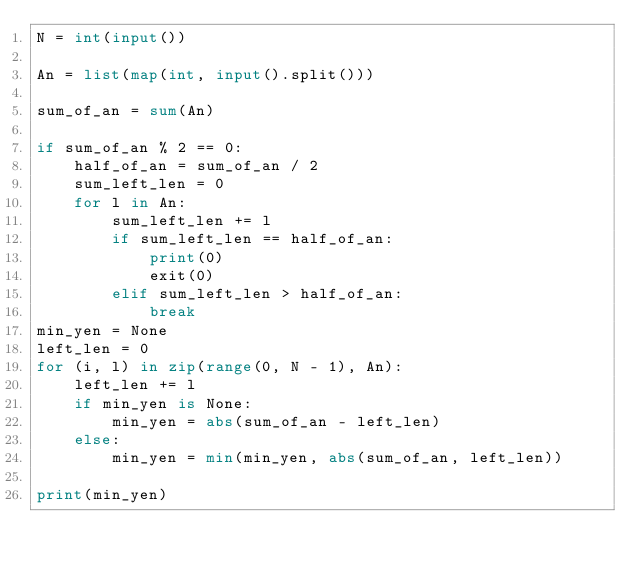Convert code to text. <code><loc_0><loc_0><loc_500><loc_500><_Python_>N = int(input())

An = list(map(int, input().split()))

sum_of_an = sum(An)

if sum_of_an % 2 == 0:
    half_of_an = sum_of_an / 2
    sum_left_len = 0
    for l in An:
        sum_left_len += l
        if sum_left_len == half_of_an:
            print(0)
            exit(0)
        elif sum_left_len > half_of_an:
            break
min_yen = None
left_len = 0
for (i, l) in zip(range(0, N - 1), An):
    left_len += l
    if min_yen is None:
        min_yen = abs(sum_of_an - left_len)
    else:
        min_yen = min(min_yen, abs(sum_of_an, left_len))

print(min_yen)</code> 